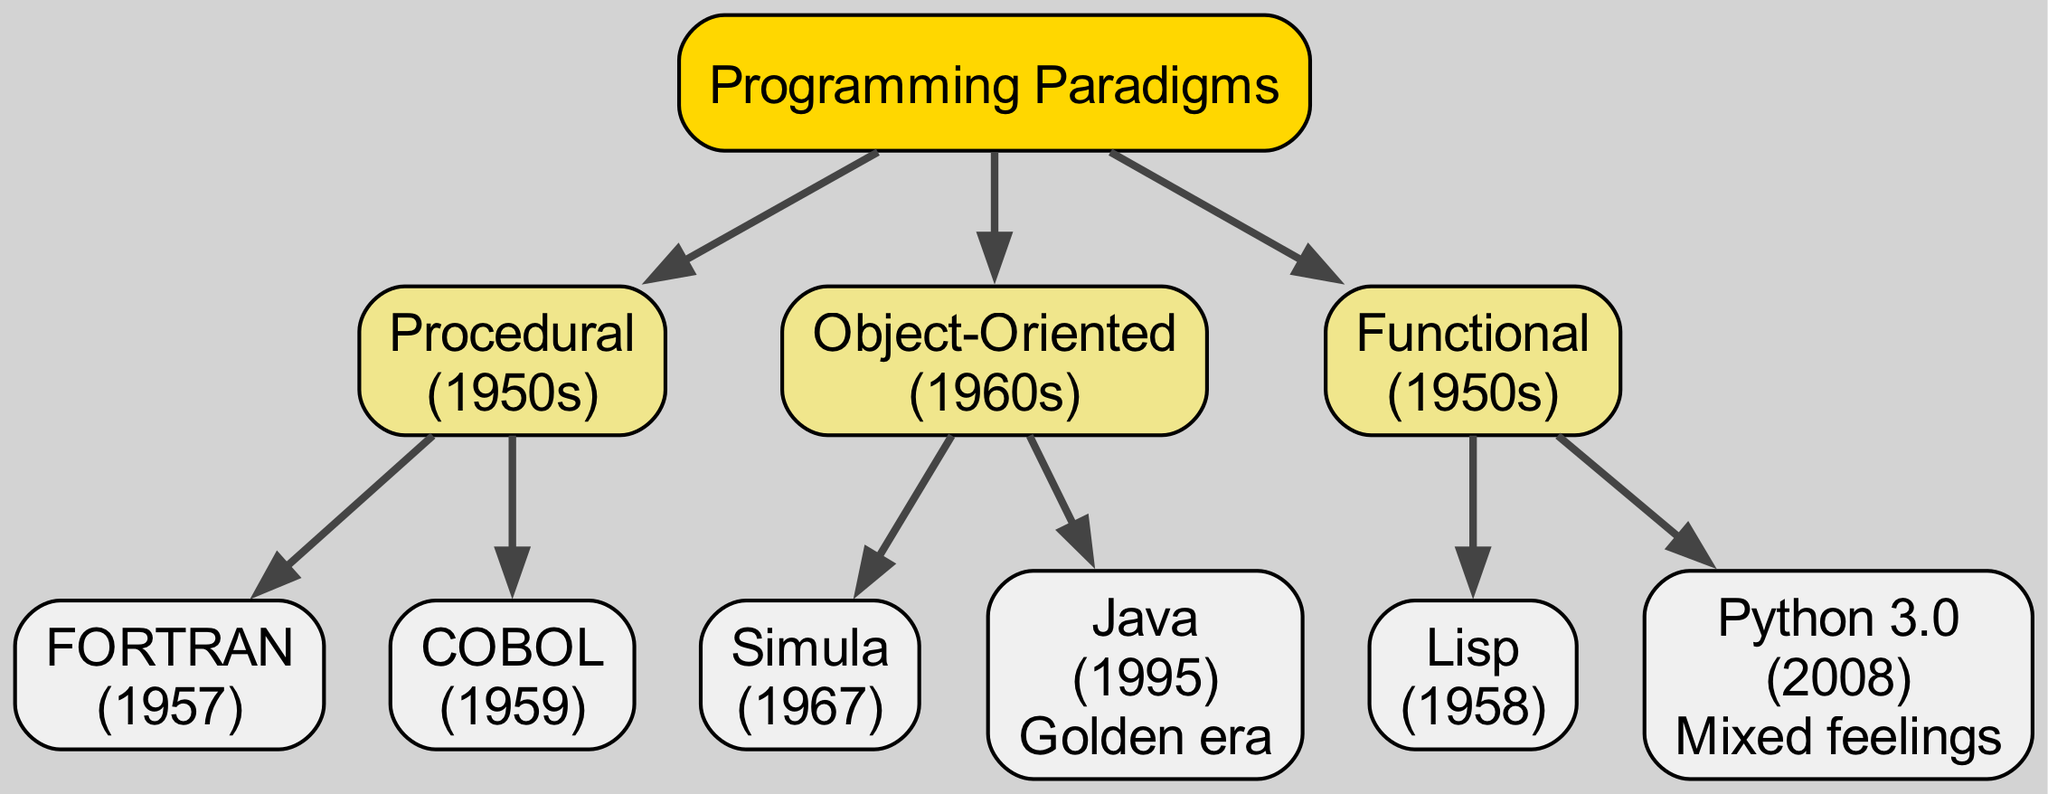What is the earliest programming paradigm shown in the diagram? The diagram indicates that "Procedural" is the first programming paradigm listed, with its start date in the 1950s.
Answer: Procedural Which programming language was introduced in 1958? The diagram reveals that "Lisp" was introduced in the year 1958 as part of the "Functional" paradigm.
Answer: Lisp How many programming languages are associated with Object-Oriented programming? According to the diagram, there are two languages listed under the Object-Oriented paradigm: "Simula" and "Java."
Answer: 2 What color represents the Object-Oriented paradigm in the diagram? The diagram specifies that the nodes related to Object-Oriented programming are colored light blue, which is indicated in the color coding section of the diagram.
Answer: Light blue Which paradigm includes Python 3.0? A careful examination of the diagram shows that Python 3.0 is categorized under the "Functional" programming paradigm.
Answer: Functional Which language is noted as the "Golden era"? The diagram indicates that "Java," introduced in 1995, is marked with the note "Golden era," signifying its significance during that period.
Answer: Java Which programming paradigm appears to have been established first: Procedural or Functional? The timeline in the diagram suggests that both "Procedural" and "Functional" paradigms emerged in the 1950s; however, the phrase "Procedural" in the diagram appears first.
Answer: Procedural How many edges are connected to the root node? By analyzing the diagram, we can see that three edges connect the root node "Programming Paradigms" to each of the three main paradigms: Procedural, Object-Oriented, and Functional.
Answer: 3 What unique feature is noted for Python 3.0 in the diagram? The diagram highlights that Python 3.0 carries the note "Mixed feelings," indicating a nuanced perspective about it within the Functional programming paradigm.
Answer: Mixed feelings 